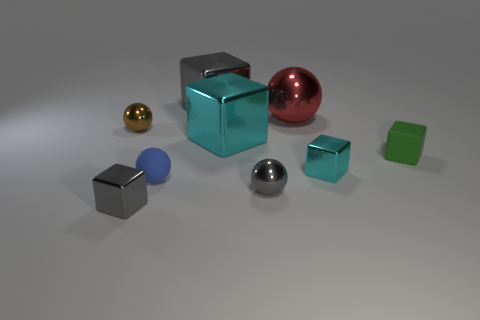Can you analyze the use of lighting in this image? The image features a soft, diffused overhead lighting that casts gentle shadows beneath the objects, enhancing the three-dimensionality of the scene. This uniform lighting helps to maintain focus on the objects' colors and textures without introducing harsh shadows or highlights, and it creates a calm, neutral atmosphere. The way the light reflects off the metallic objects also suggests the main light source is situated above and slightly to the front of the composition. 